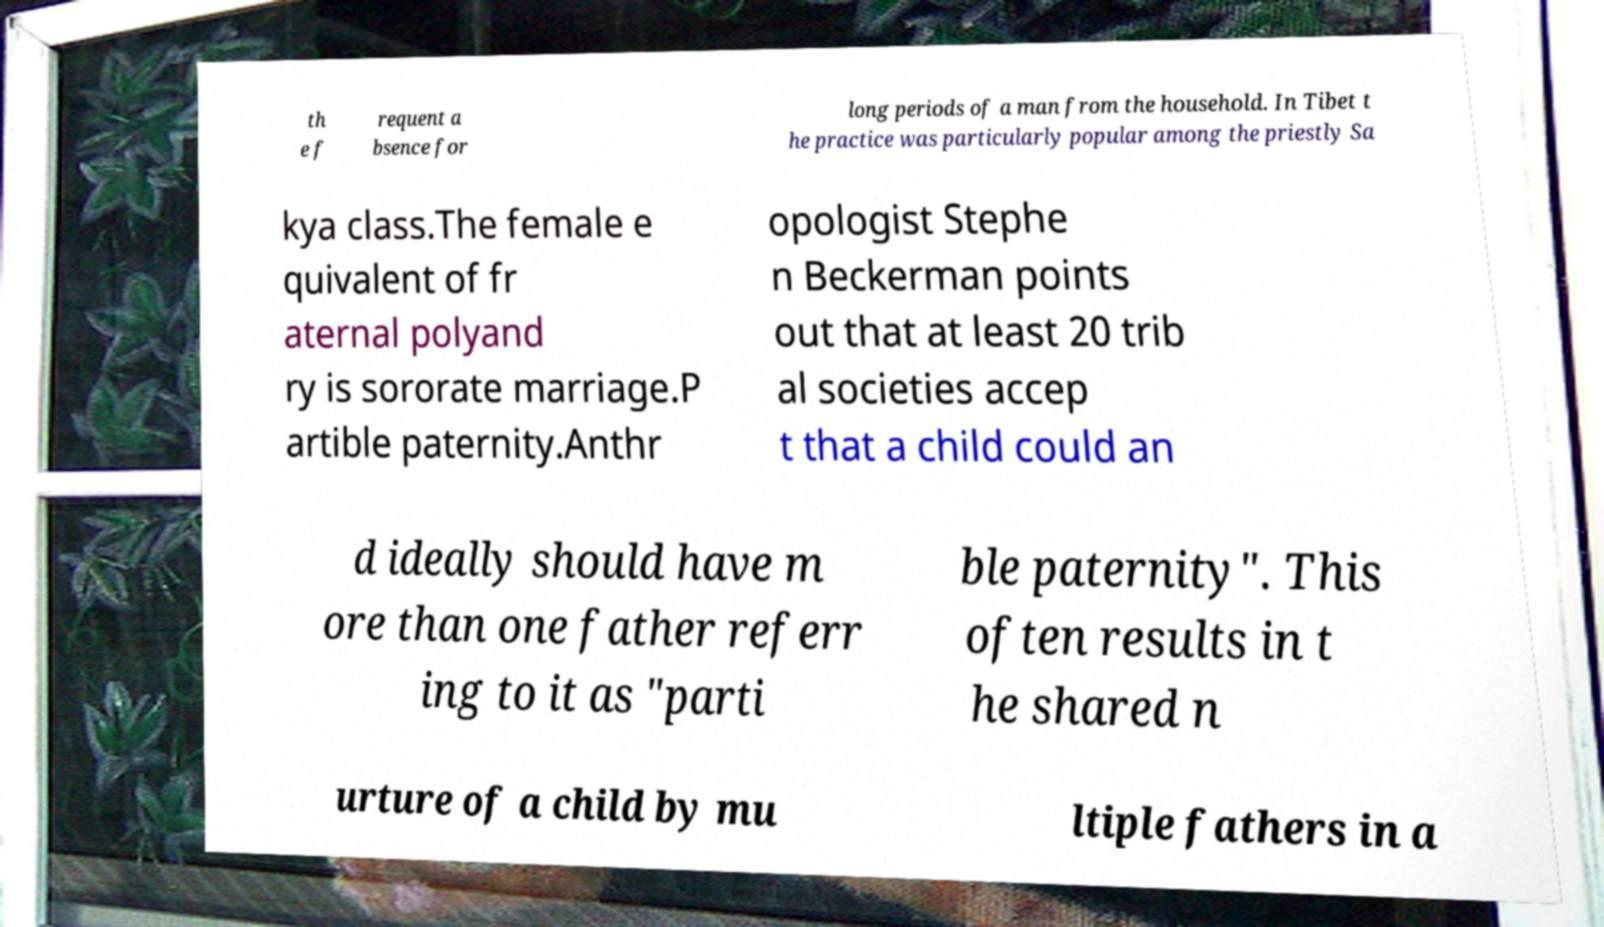I need the written content from this picture converted into text. Can you do that? th e f requent a bsence for long periods of a man from the household. In Tibet t he practice was particularly popular among the priestly Sa kya class.The female e quivalent of fr aternal polyand ry is sororate marriage.P artible paternity.Anthr opologist Stephe n Beckerman points out that at least 20 trib al societies accep t that a child could an d ideally should have m ore than one father referr ing to it as "parti ble paternity". This often results in t he shared n urture of a child by mu ltiple fathers in a 